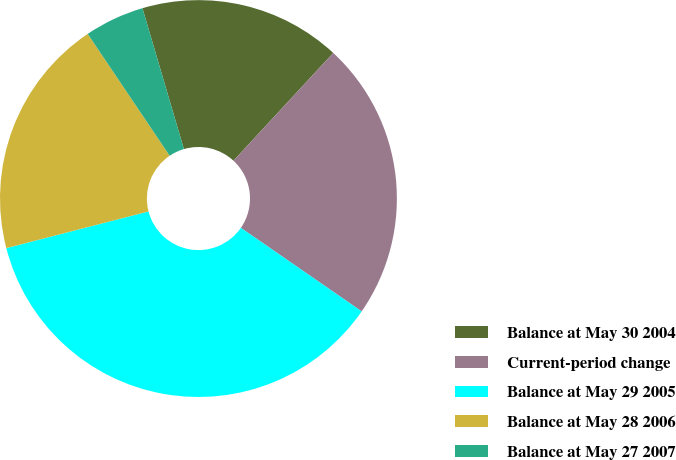Convert chart. <chart><loc_0><loc_0><loc_500><loc_500><pie_chart><fcel>Balance at May 30 2004<fcel>Current-period change<fcel>Balance at May 29 2005<fcel>Balance at May 28 2006<fcel>Balance at May 27 2007<nl><fcel>16.44%<fcel>22.74%<fcel>36.35%<fcel>19.59%<fcel>4.87%<nl></chart> 